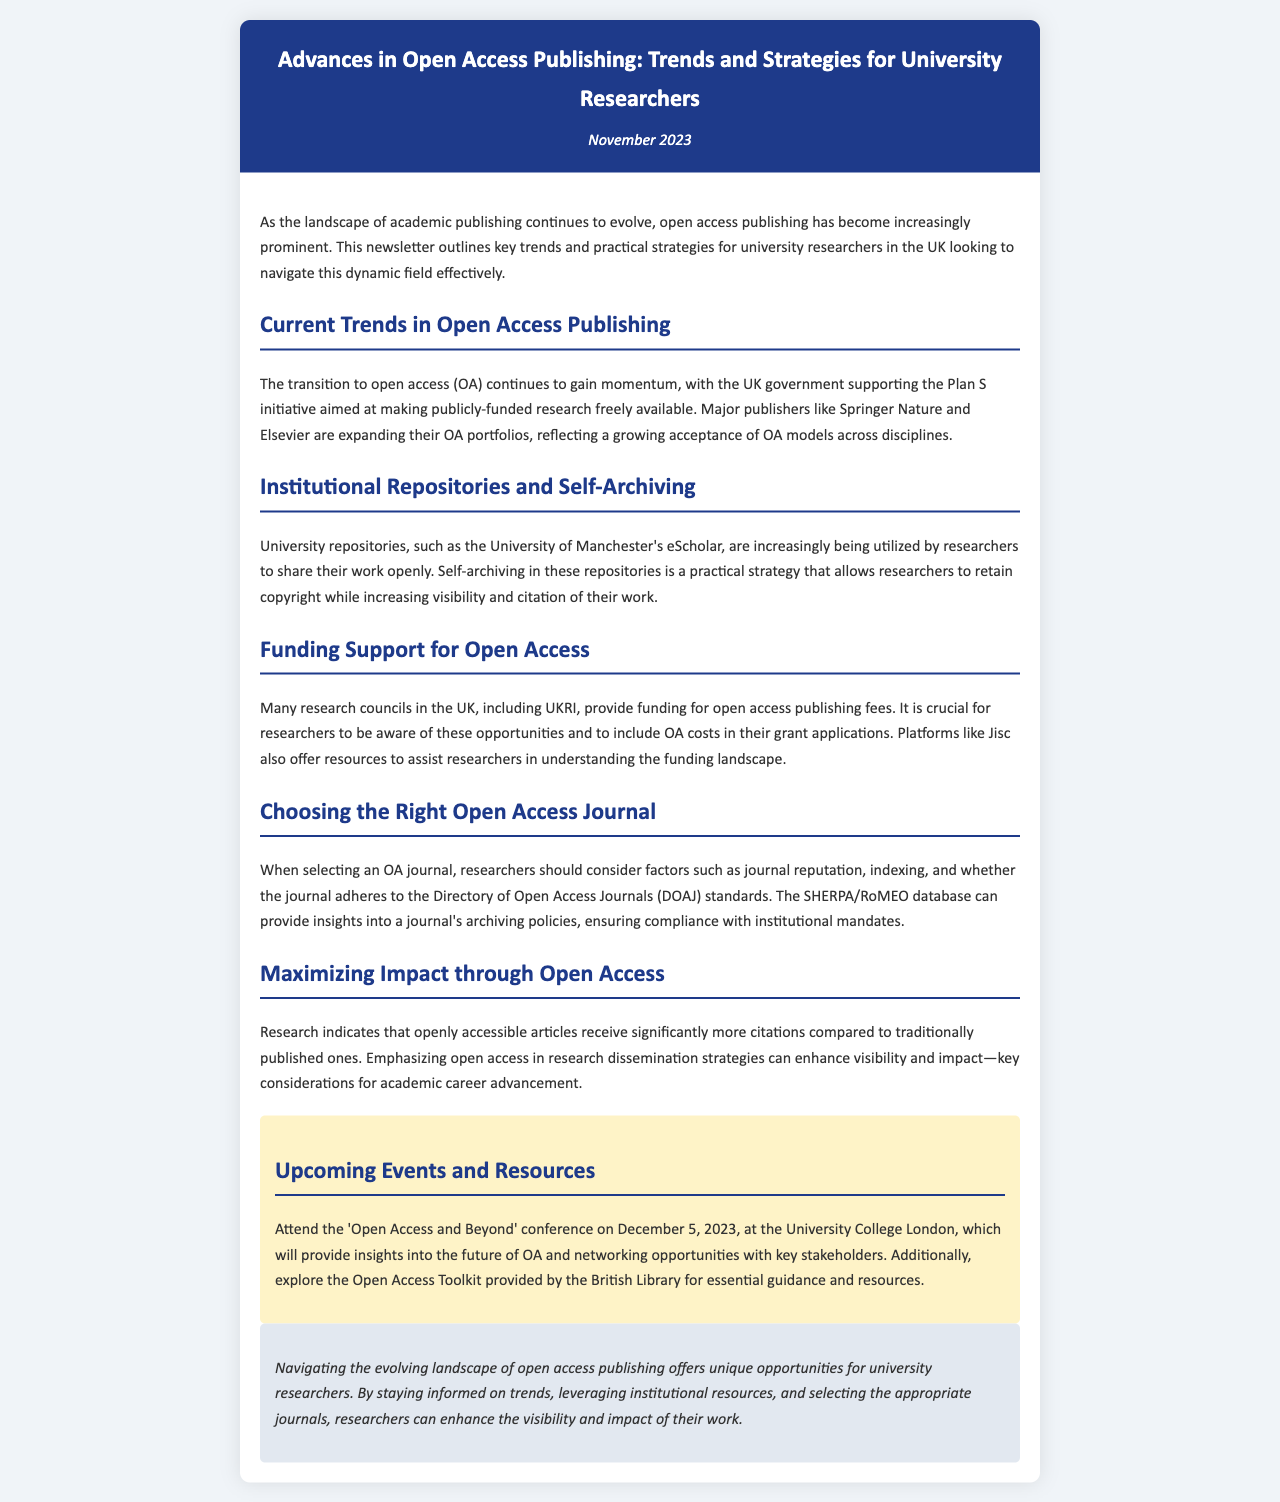What is the title of the newsletter? The title of the newsletter is presented prominently at the top of the document.
Answer: Advances in Open Access Publishing: Trends and Strategies for University Researchers When is the newsletter published? The publication date is mentioned just below the title in the header section.
Answer: November 2023 What initiative is the UK government supporting? The document states a government initiative aimed at enhancing open access publishing within the UK.
Answer: Plan S Which platform offers resources for understanding open access funding? The newsletter references a platform that assists researchers in navigating the funding landscape for open access publishing.
Answer: Jisc What is one strategy for researchers to increase visibility of their work? The content explains a practical approach for researchers to share their research while retaining rights.
Answer: Self-archiving What is a significant benefit of open access articles mentioned in the newsletter? The document highlights an important advantage for articles published under open access models.
Answer: More citations When is the 'Open Access and Beyond' conference scheduled? The specific date of the conference is provided in the events section of the newsletter.
Answer: December 5, 2023 Which database can help researchers check journal compliance with institutional mandates? The newsletter points to a specific resource for evaluating journals concerning archiving policies.
Answer: SHERPA/RoMEO What color is used for the header background in the document? The design of the newsletter specifies the color used in the header for visual clarity.
Answer: Dark blue 